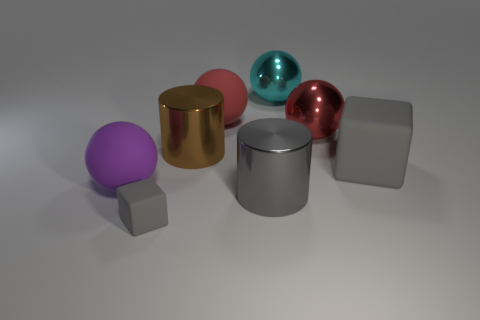Is the color of the rubber block that is to the left of the cyan metallic thing the same as the big cube?
Provide a succinct answer. Yes. There is a purple object that is the same size as the cyan object; what shape is it?
Offer a very short reply. Sphere. Does the metallic object that is in front of the purple ball have the same size as the big cyan shiny sphere?
Provide a succinct answer. Yes. What material is the block that is the same size as the purple rubber ball?
Provide a short and direct response. Rubber. Are there any big metal things that are in front of the big rubber sphere in front of the large matte thing on the right side of the red metal sphere?
Your answer should be very brief. Yes. There is a big matte sphere that is behind the large gray matte cube; is its color the same as the metallic ball in front of the large cyan metallic thing?
Provide a short and direct response. Yes. Is there a big brown shiny object?
Keep it short and to the point. Yes. There is a large thing that is the same color as the big rubber cube; what material is it?
Your response must be concise. Metal. There is a object that is to the left of the gray matte cube in front of the rubber cube on the right side of the brown metallic cylinder; what size is it?
Provide a succinct answer. Large. There is a large brown object; does it have the same shape as the shiny thing that is in front of the large gray rubber block?
Provide a succinct answer. Yes. 